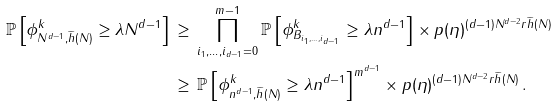Convert formula to latex. <formula><loc_0><loc_0><loc_500><loc_500>\mathbb { P } \left [ \phi ^ { k } _ { N ^ { d - 1 } , \widetilde { h } ( N ) } \geq \lambda N ^ { d - 1 } \right ] & \, \geq \, \prod _ { i _ { 1 } , \dots , i _ { d - 1 } = 0 } ^ { m - 1 } \mathbb { P } \left [ \phi ^ { k } _ { B _ { i _ { 1 } , \dots , i _ { d - 1 } } } \geq \lambda n ^ { d - 1 } \right ] \times p ( \eta ) ^ { ( d - 1 ) N ^ { d - 2 } r \widetilde { h } ( N ) } \\ & \, \geq \, \mathbb { P } \left [ \phi ^ { k } _ { n ^ { d - 1 } , \widetilde { h } ( N ) } \geq \lambda n ^ { d - 1 } \right ] ^ { m ^ { d - 1 } } \times p ( \eta ) ^ { ( d - 1 ) N ^ { d - 2 } r \widetilde { h } ( N ) } \, . \\</formula> 